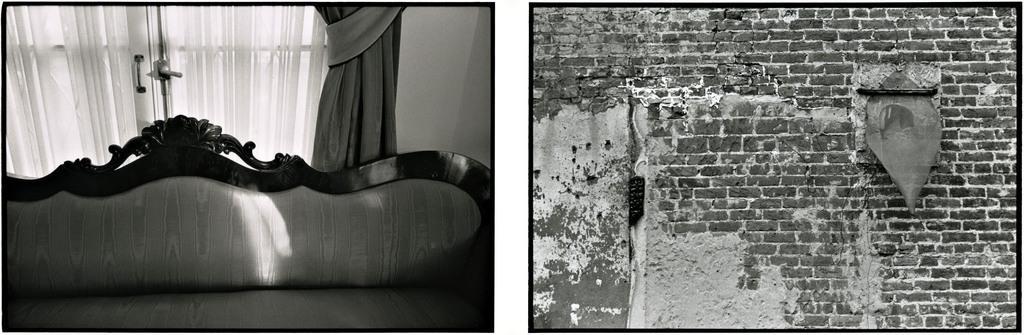Please provide a concise description of this image. There are two images. Here we can see a sofa, curtain, door, and a wall. And there is a wall. 